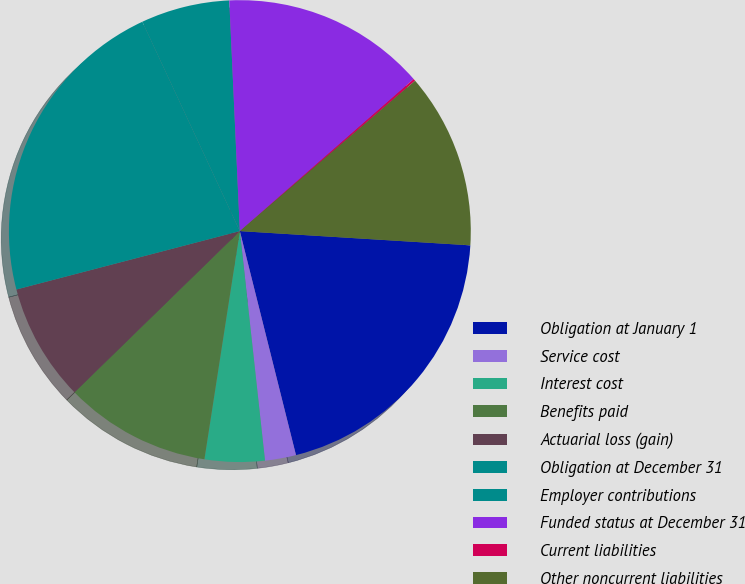<chart> <loc_0><loc_0><loc_500><loc_500><pie_chart><fcel>Obligation at January 1<fcel>Service cost<fcel>Interest cost<fcel>Benefits paid<fcel>Actuarial loss (gain)<fcel>Obligation at December 31<fcel>Employer contributions<fcel>Funded status at December 31<fcel>Current liabilities<fcel>Other noncurrent liabilities<nl><fcel>20.11%<fcel>2.17%<fcel>4.19%<fcel>10.25%<fcel>8.23%<fcel>22.13%<fcel>6.21%<fcel>14.29%<fcel>0.15%<fcel>12.27%<nl></chart> 